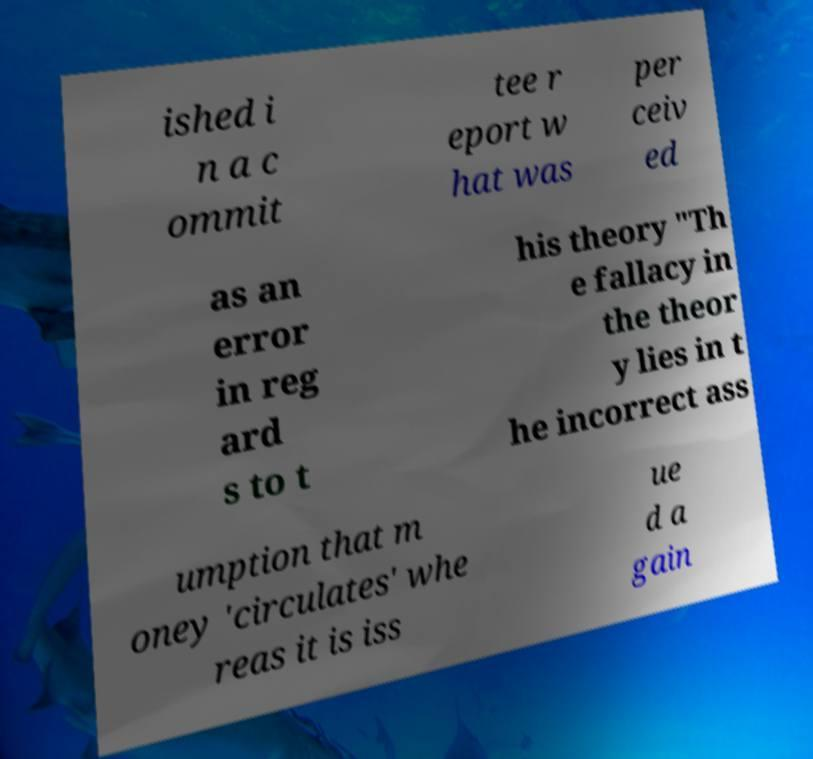Please identify and transcribe the text found in this image. ished i n a c ommit tee r eport w hat was per ceiv ed as an error in reg ard s to t his theory "Th e fallacy in the theor y lies in t he incorrect ass umption that m oney 'circulates' whe reas it is iss ue d a gain 